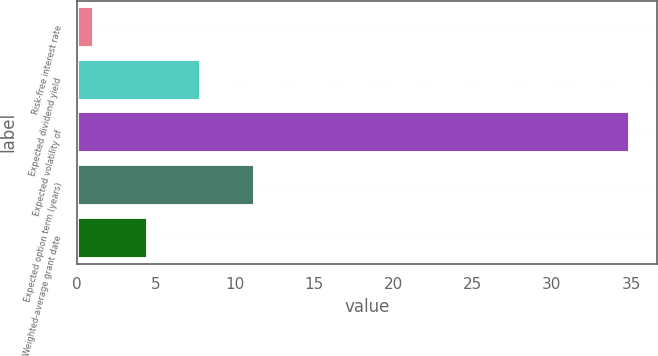Convert chart to OTSL. <chart><loc_0><loc_0><loc_500><loc_500><bar_chart><fcel>Risk-free interest rate<fcel>Expected dividend yield<fcel>Expected volatility of<fcel>Expected option term (years)<fcel>Weighted-average grant date<nl><fcel>1.1<fcel>7.86<fcel>34.9<fcel>11.24<fcel>4.48<nl></chart> 